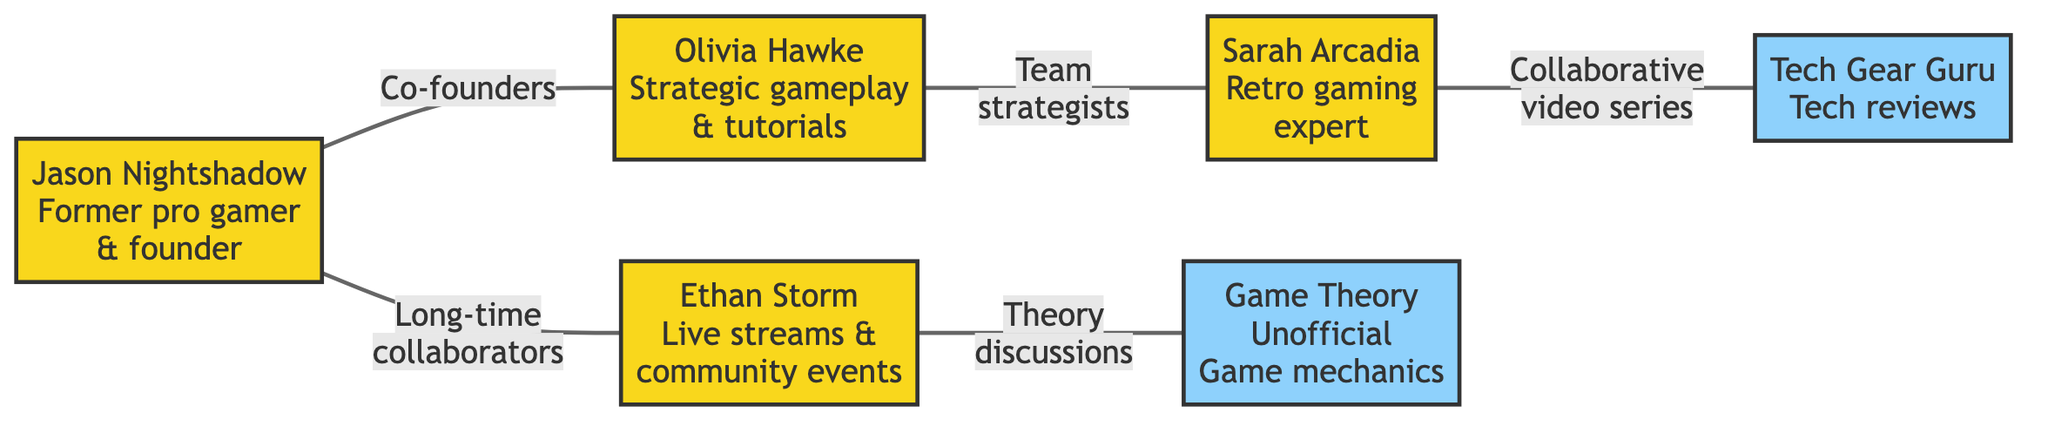What is the total number of nodes in the graph? The graph contains six nodes, as listed in the data. These nodes are Jason Nightshadow, Olivia Hawke, Ethan Storm, Sarah Arcadia, Tech Gear Guru, and Game Theory Unofficial.
Answer: 6 Who is known for strategic gameplays and in-depth tutorials? According to the diagram, Olivia Hawke is specifically noted for her strategic gameplays and in-depth tutorials on the channel.
Answer: Olivia Hawke What is the relationship between Jason Nightshadow and Ethan Storm? The diagram indicates that Jason Nightshadow and Ethan Storm have a relationship characterized as "Long-time collaborators."
Answer: Long-time collaborators Which member specializes in retro gaming? From the information provided, Sarah Arcadia is identified as the expert in retro gaming and nostalgic content creation.
Answer: Sarah Arcadia How many edges connect to Sarah Arcadia? By examining the edges, Sarah Arcadia has one edge connecting her to Tech Gear Guru and one to Olivia Hawke, resulting in two edges in total.
Answer: 2 What type of collaborator is Tech Gear Guru? The diagram classifies Tech Gear Guru as a "Content Collaborator," indicating that he provides content about tech reviews and gaming gear.
Answer: Content Collaborator Which members are directly connected to Olivia Hawke? Olivia Hawke is directly connected to Jason Nightshadow as a co-founder and to Sarah Arcadia as team strategists, making the connections immediate.
Answer: Jason Nightshadow and Sarah Arcadia What relation exists between Ethan Storm and Game Theory Unofficial? The relationship noted in the graph between Ethan Storm and Game Theory Unofficial involves "Theory discussions," which indicates a collaborative focus on theories related to gaming.
Answer: Theory discussions Who has a direct collaborative relationship with Tech Gear Guru? The diagram highlights that Sarah Arcadia has a collaborative relationship with Tech Gear Guru, specifically mentioned as a "Collaborative video series."
Answer: Sarah Arcadia 